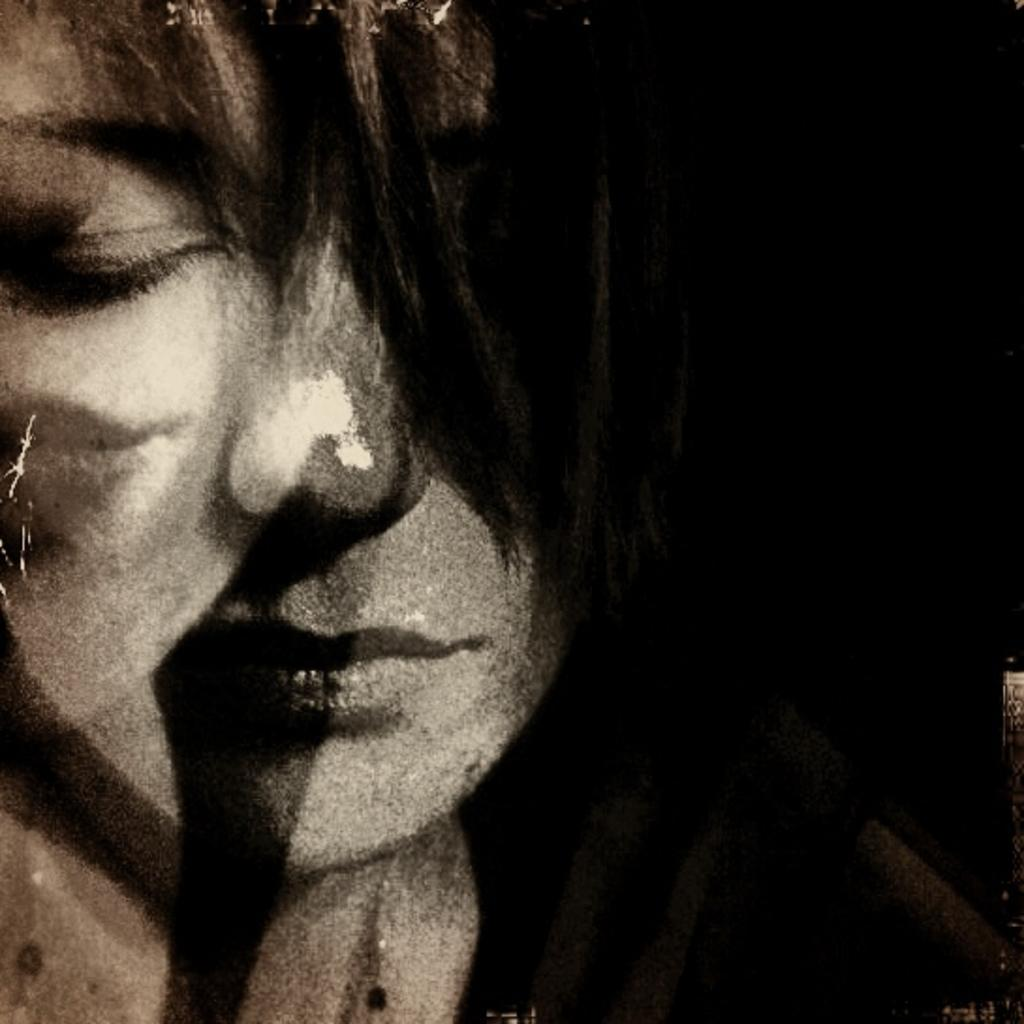What is the main subject of the image? There is a person in the image. Can you describe the background of the image? The background of the image is dark. What type of hose is being used by the person in the image? There is no hose present in the image. Is the person in the image crying? The image does not provide any information about the person's emotions, so it cannot be determined if they are crying. 